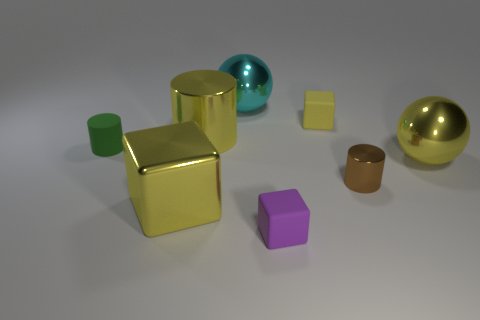What number of other things are there of the same shape as the small green object?
Your response must be concise. 2. Does the big sphere that is to the right of the brown cylinder have the same color as the small metallic cylinder?
Your answer should be compact. No. What number of other objects are there of the same size as the purple matte cube?
Keep it short and to the point. 3. Is the material of the cyan ball the same as the large yellow cylinder?
Keep it short and to the point. Yes. The block that is behind the yellow metallic object that is to the right of the big yellow metallic cylinder is what color?
Your answer should be compact. Yellow. The other metallic thing that is the same shape as the large cyan metallic thing is what size?
Provide a short and direct response. Large. Is the color of the large block the same as the tiny matte cylinder?
Offer a very short reply. No. There is a tiny matte object in front of the cylinder right of the small yellow cube; how many large shiny objects are to the right of it?
Offer a terse response. 1. Are there more tiny rubber objects than small purple rubber blocks?
Offer a very short reply. Yes. How many green objects are there?
Provide a short and direct response. 1. 